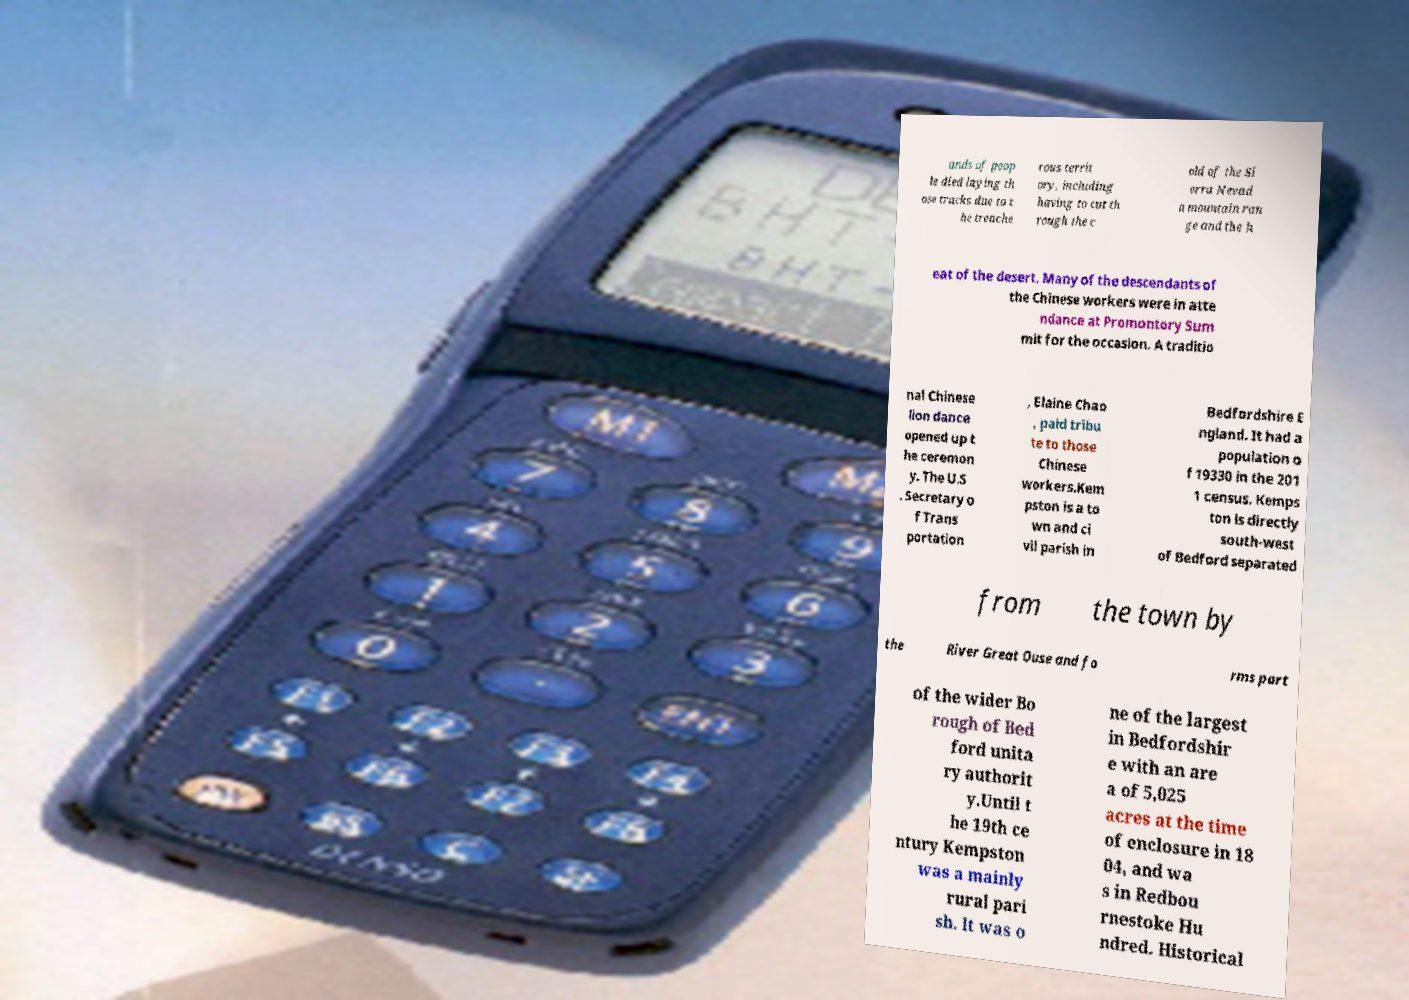There's text embedded in this image that I need extracted. Can you transcribe it verbatim? ands of peop le died laying th ose tracks due to t he treache rous territ ory, including having to cut th rough the c old of the Si erra Nevad a mountain ran ge and the h eat of the desert. Many of the descendants of the Chinese workers were in atte ndance at Promontory Sum mit for the occasion. A traditio nal Chinese lion dance opened up t he ceremon y. The U.S . Secretary o f Trans portation , Elaine Chao , paid tribu te to those Chinese workers.Kem pston is a to wn and ci vil parish in Bedfordshire E ngland. It had a population o f 19330 in the 201 1 census. Kemps ton is directly south-west of Bedford separated from the town by the River Great Ouse and fo rms part of the wider Bo rough of Bed ford unita ry authorit y.Until t he 19th ce ntury Kempston was a mainly rural pari sh. It was o ne of the largest in Bedfordshir e with an are a of 5,025 acres at the time of enclosure in 18 04, and wa s in Redbou rnestoke Hu ndred. Historical 